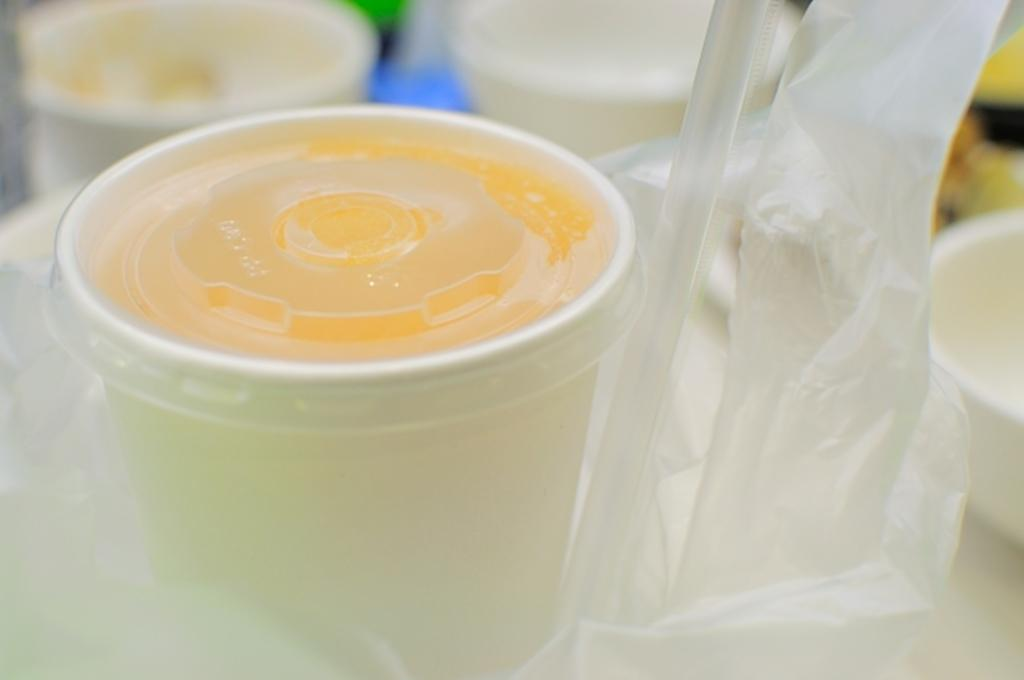What is contained in the cup that is visible in the image? There is a cup with a lid in the image. What is used for drinking in the image? There is a straw in the image for drinking. What can be used for cleaning or wiping in the image? Tissue papers are present in the image for cleaning or wiping. How many horses are present in the image? There are no horses present in the image. What type of stick is used to stir the contents of the cup in the image? There is no stick visible in the image, and the contents of the cup are not being stirred. 